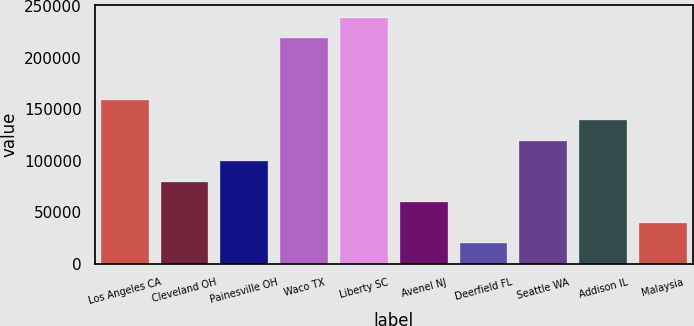Convert chart to OTSL. <chart><loc_0><loc_0><loc_500><loc_500><bar_chart><fcel>Los Angeles CA<fcel>Cleveland OH<fcel>Painesville OH<fcel>Waco TX<fcel>Liberty SC<fcel>Avenel NJ<fcel>Deerfield FL<fcel>Seattle WA<fcel>Addison IL<fcel>Malaysia<nl><fcel>159300<fcel>79700<fcel>99600<fcel>218800<fcel>238700<fcel>59800<fcel>20000<fcel>119500<fcel>139400<fcel>39900<nl></chart> 